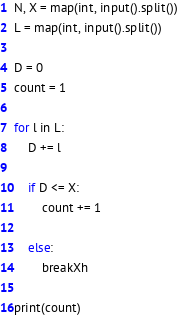<code> <loc_0><loc_0><loc_500><loc_500><_Python_>N, X = map(int, input().split())
L = map(int, input().split())

D = 0
count = 1

for l in L:
    D += l

    if D <= X:
        count += 1

    else:
        breakXh

print(count)
</code> 